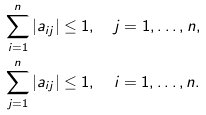<formula> <loc_0><loc_0><loc_500><loc_500>\sum _ { i = 1 } ^ { n } | a _ { i j } | & \leq 1 , \quad j = 1 , \hdots , n , \\ \sum _ { j = 1 } ^ { n } | a _ { i j } | & \leq 1 , \quad i = 1 , \hdots , n .</formula> 